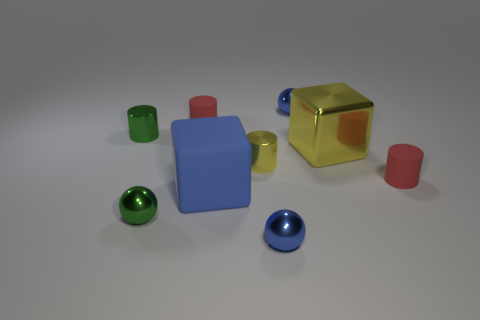There is a tiny yellow thing on the left side of the small shiny sphere behind the big yellow cube; how many large yellow metal cubes are behind it?
Provide a short and direct response. 1. There is a rubber thing that is to the left of the metal block and in front of the big shiny cube; what is its shape?
Your response must be concise. Cube. Are there fewer big yellow shiny blocks to the left of the big yellow shiny object than green metal things?
Make the answer very short. Yes. How many tiny objects are either yellow cubes or metal objects?
Provide a succinct answer. 5. What is the size of the yellow metallic block?
Offer a terse response. Large. Is there any other thing that has the same material as the tiny green cylinder?
Offer a terse response. Yes. There is a large yellow thing; how many small red things are behind it?
Make the answer very short. 1. What is the size of the other metallic object that is the same shape as the small yellow shiny thing?
Ensure brevity in your answer.  Small. There is a rubber object that is left of the large yellow object and in front of the big yellow thing; what is its size?
Ensure brevity in your answer.  Large. Does the large rubber thing have the same color as the matte object to the right of the blue cube?
Your answer should be compact. No. 